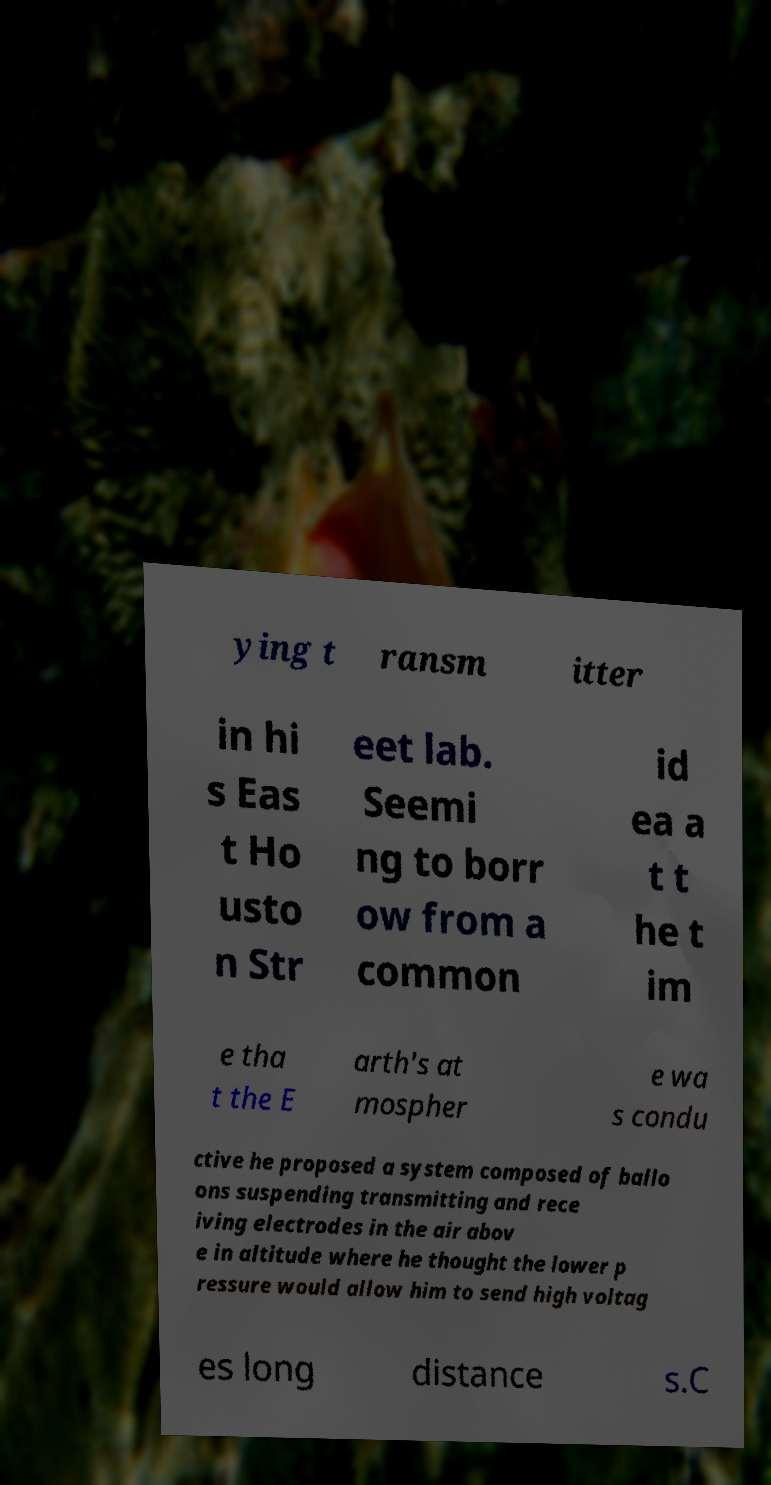What messages or text are displayed in this image? I need them in a readable, typed format. ying t ransm itter in hi s Eas t Ho usto n Str eet lab. Seemi ng to borr ow from a common id ea a t t he t im e tha t the E arth's at mospher e wa s condu ctive he proposed a system composed of ballo ons suspending transmitting and rece iving electrodes in the air abov e in altitude where he thought the lower p ressure would allow him to send high voltag es long distance s.C 